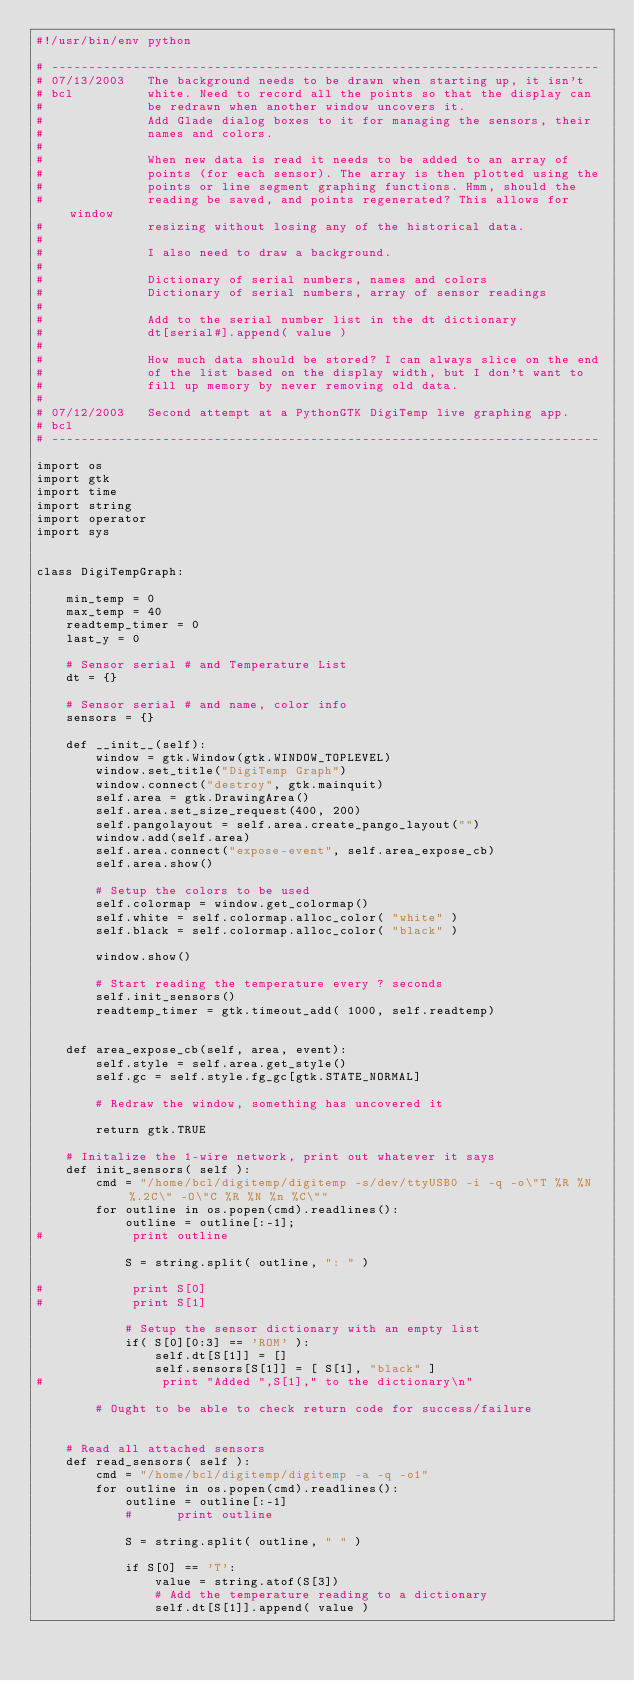<code> <loc_0><loc_0><loc_500><loc_500><_Python_>#!/usr/bin/env python

# --------------------------------------------------------------------------
# 07/13/2003   The background needs to be drawn when starting up, it isn't
# bcl          white. Need to record all the points so that the display can
#              be redrawn when another window uncovers it.
#              Add Glade dialog boxes to it for managing the sensors, their
#              names and colors.
#
#              When new data is read it needs to be added to an array of
#              points (for each sensor). The array is then plotted using the
#              points or line segment graphing functions. Hmm, should the
#              reading be saved, and points regenerated? This allows for window
#              resizing without losing any of the historical data.
#
#              I also need to draw a background.
#
#              Dictionary of serial numbers, names and colors
#              Dictionary of serial numbers, array of sensor readings
#
#              Add to the serial number list in the dt dictionary
#              dt[serial#].append( value )
#
#              How much data should be stored? I can always slice on the end
#              of the list based on the display width, but I don't want to
#              fill up memory by never removing old data.
#
# 07/12/2003   Second attempt at a PythonGTK DigiTemp live graphing app.
# bcl
# --------------------------------------------------------------------------

import os
import gtk
import time
import string
import operator
import sys


class DigiTempGraph:

    min_temp = 0
    max_temp = 40
    readtemp_timer = 0
    last_y = 0

    # Sensor serial # and Temperature List
    dt = {}

    # Sensor serial # and name, color info
    sensors = {}

    def __init__(self):
        window = gtk.Window(gtk.WINDOW_TOPLEVEL)
        window.set_title("DigiTemp Graph")
        window.connect("destroy", gtk.mainquit)
        self.area = gtk.DrawingArea()
        self.area.set_size_request(400, 200)
        self.pangolayout = self.area.create_pango_layout("")
        window.add(self.area)
        self.area.connect("expose-event", self.area_expose_cb)
        self.area.show()

        # Setup the colors to be used
        self.colormap = window.get_colormap()
        self.white = self.colormap.alloc_color( "white" )
        self.black = self.colormap.alloc_color( "black" )

        window.show()

        # Start reading the temperature every ? seconds
        self.init_sensors()
        readtemp_timer = gtk.timeout_add( 1000, self.readtemp)


    def area_expose_cb(self, area, event):
        self.style = self.area.get_style()
        self.gc = self.style.fg_gc[gtk.STATE_NORMAL]

        # Redraw the window, something has uncovered it

        return gtk.TRUE

    # Initalize the 1-wire network, print out whatever it says
    def init_sensors( self ):
        cmd = "/home/bcl/digitemp/digitemp -s/dev/ttyUSB0 -i -q -o\"T %R %N %.2C\" -O\"C %R %N %n %C\""
        for outline in os.popen(cmd).readlines():
            outline = outline[:-1];
#            print outline

            S = string.split( outline, ": " )

#            print S[0]
#            print S[1]

            # Setup the sensor dictionary with an empty list
            if( S[0][0:3] == 'ROM' ):
                self.dt[S[1]] = []
                self.sensors[S[1]] = [ S[1], "black" ]
#                print "Added ",S[1]," to the dictionary\n"
                
        # Ought to be able to check return code for success/failure


    # Read all attached sensors
    def read_sensors( self ):
        cmd = "/home/bcl/digitemp/digitemp -a -q -o1"
        for outline in os.popen(cmd).readlines():
            outline = outline[:-1]
            #      print outline

            S = string.split( outline, " " )

            if S[0] == 'T':
                value = string.atof(S[3])
                # Add the temperature reading to a dictionary
                self.dt[S[1]].append( value )
</code> 